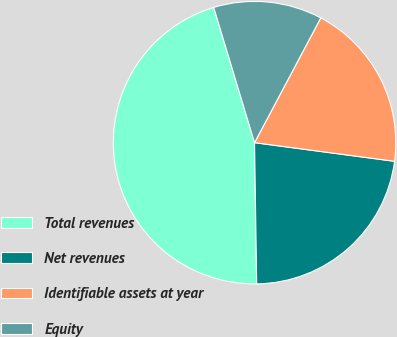<chart> <loc_0><loc_0><loc_500><loc_500><pie_chart><fcel>Total revenues<fcel>Net revenues<fcel>Identifiable assets at year<fcel>Equity<nl><fcel>45.58%<fcel>22.65%<fcel>19.34%<fcel>12.43%<nl></chart> 